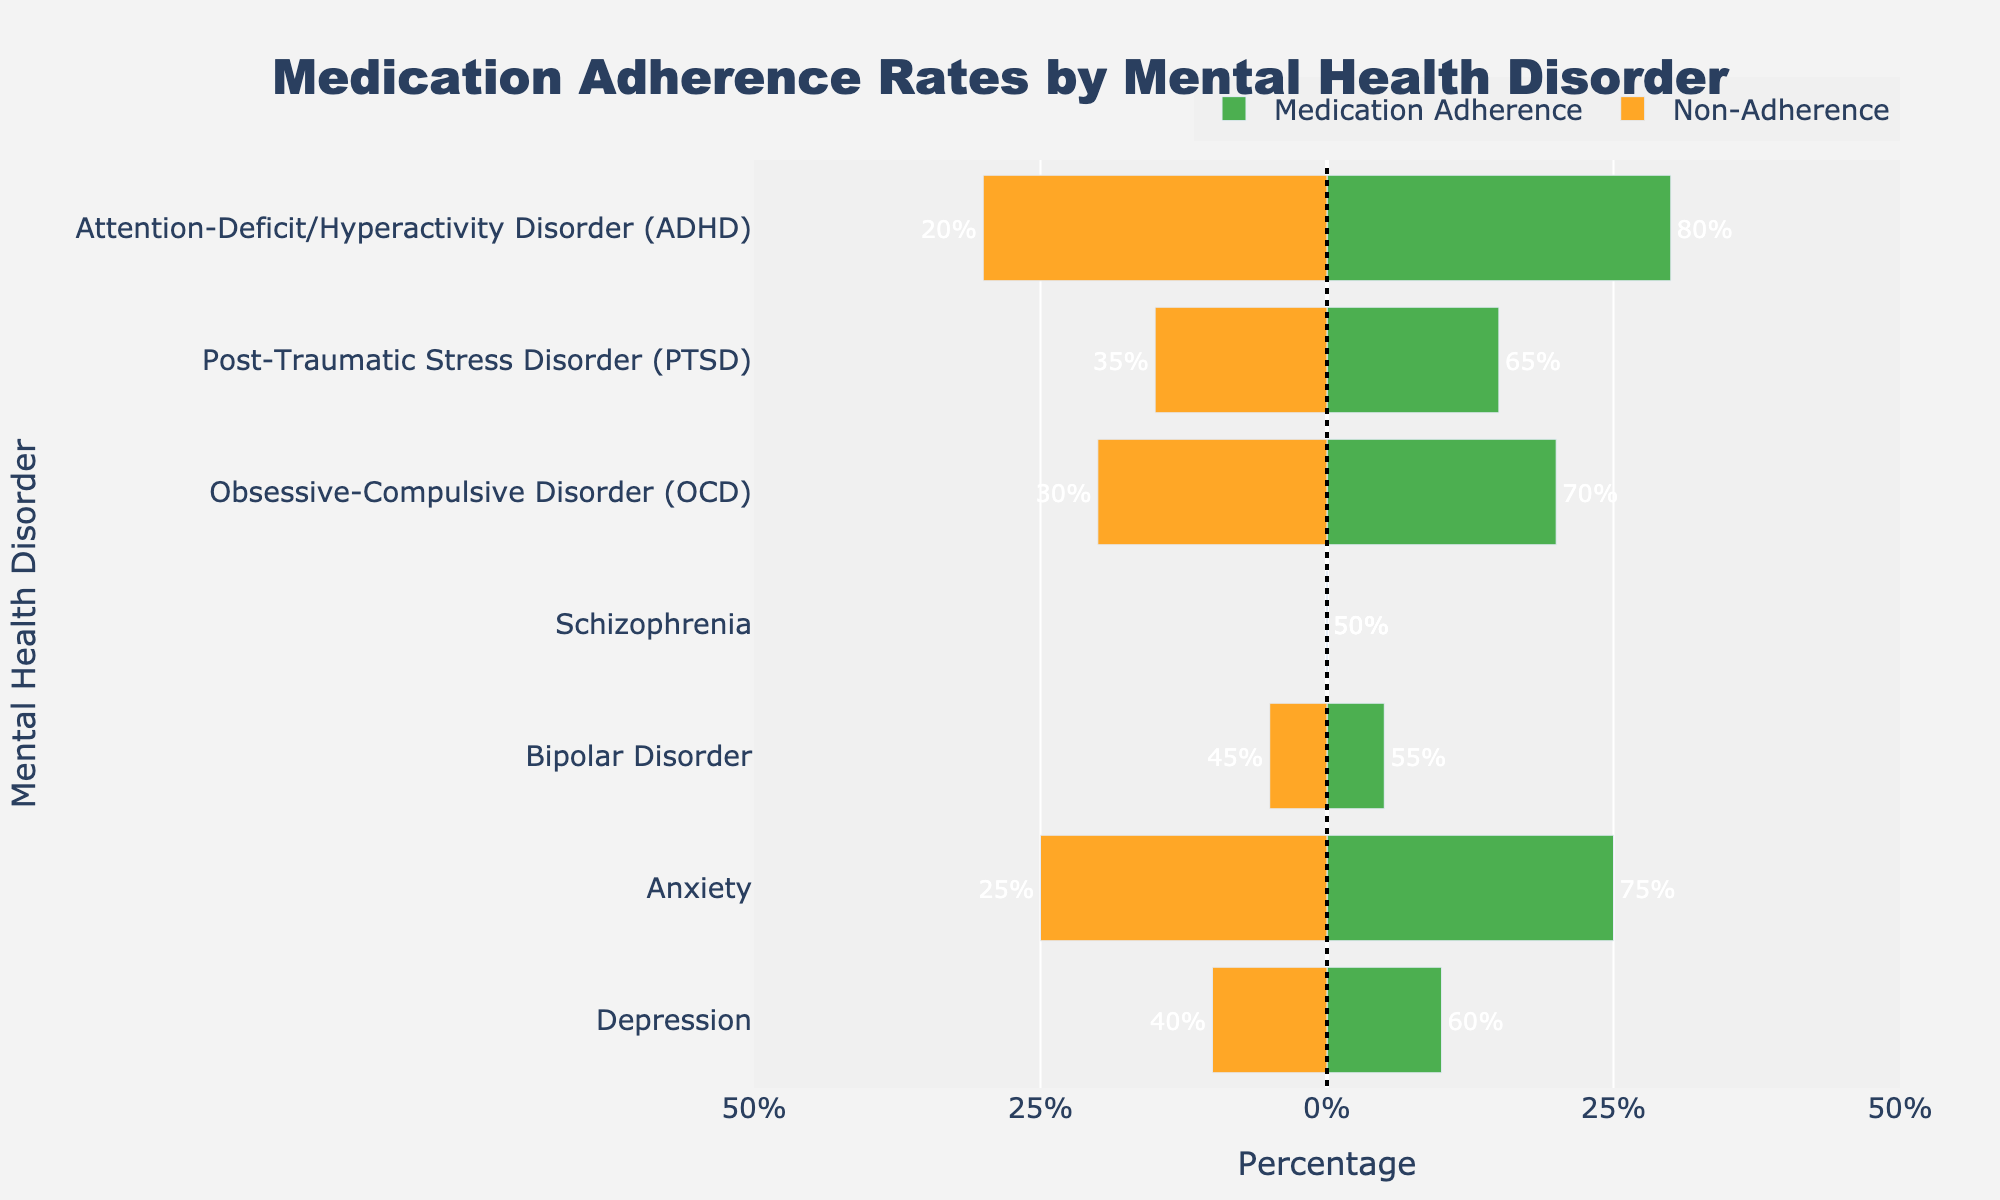Which mental health disorder has the highest medication adherence rate? By comparing the lengths of the green bars (which represent adherence), we see that ADHD has the highest adherence rate at 80%.
Answer: ADHD Which mental health disorder has the lowest medication adherence rate? By comparing the lengths of the green bars, schizophrenia has the shortest green bar, indicating the lowest adherence rate at 50%.
Answer: Schizophrenia What is the average medication adherence rate across all mental health disorders? Sum the adherence rates for all disorders: 60 (Depression) + 75 (Anxiety) + 55 (Bipolar Disorder) + 50 (Schizophrenia) + 70 (OCD) + 65 (PTSD) + 80 (ADHD) = 455. There are 7 disorders, so the average adherence rate is 455 / 7 ≈ 65%.
Answer: 65% How much greater is medication adherence for ADHD compared to schizophrenia? ADHD has an adherence rate of 80%, and schizophrenia has an adherence rate of 50%. The difference is 80% - 50% = 30%.
Answer: 30% Which disorder has the closest adherence and non-adherence rates? By looking at the bars, schizophrenia has the most equal adherence (50%) and non-adherence (50%) rates.
Answer: Schizophrenia List the disorders in ascending order of their non-adherence rates. The non-adherence rates are: ADHD (20%), Anxiety (25%), OCD (30%), PTSD (35%), Depression (40%), Bipolar Disorder (45%), Schizophrenia (50%). Therefore, the order is ADHD, Anxiety, OCD, PTSD, Depression, Bipolar Disorder, Schizophrenia.
Answer: ADHD, Anxiety, OCD, PTSD, Depression, Bipolar Disorder, Schizophrenia What is the range of medication adherence rates among the disorders? The highest adherence rate is 80% (ADHD) and the lowest is 50% (Schizophrenia). The range is 80% - 50% = 30%.
Answer: 30% Which disorders have a medication adherence rate greater than 60%? The disorders with adherence rates greater than 60% are Anxiety (75%), OCD (70%), PTSD (65%), and ADHD (80%).
Answer: Anxiety, OCD, PTSD, ADHD What is the proportion of disorders with adherence rates below the average? The average adherence rate is 65%. Disorders below this rate are Depression (60%), Bipolar Disorder (55%), and Schizophrenia (50%). There are 3 out of 7 disorders below average. The proportion is 3/7 ≈ 0.43 or 43%.
Answer: 43% 